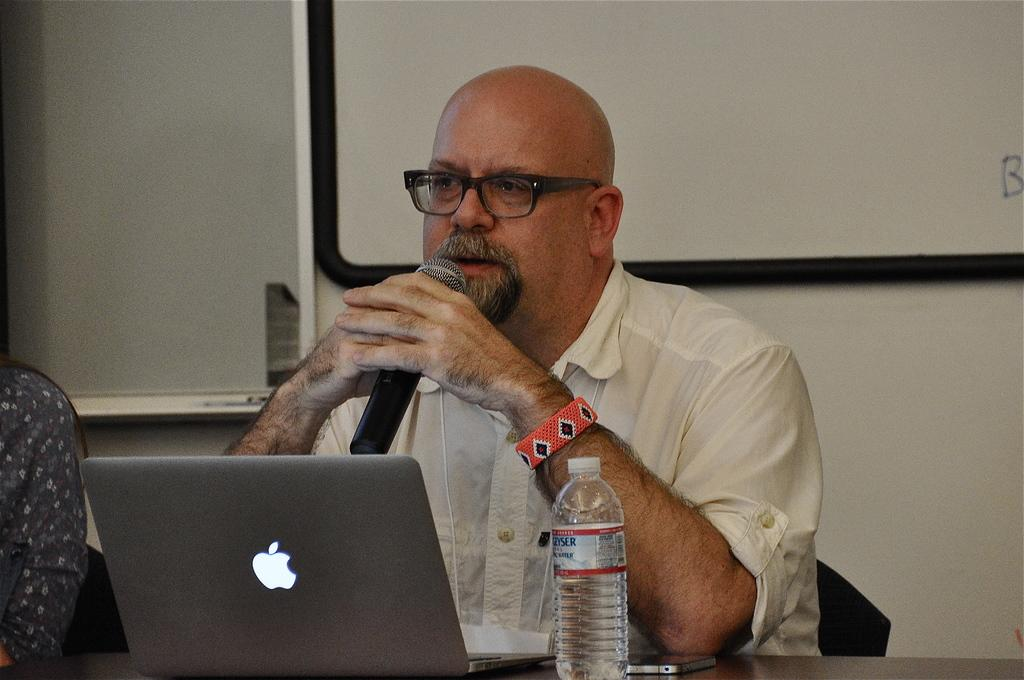What is the main subject of the image? There is a man in the image. What is the man doing in the image? The man is sitting and speaking. What is the man holding in his hand? The man is holding a microphone in his hand. What objects are on the table behind the man? There is a laptop and a water bottle on the table. What other electronic device is on the table? There is a cell phone on the table. What type of island can be seen in the background of the image? There is no island visible in the image; it features a man sitting and speaking with a microphone, a laptop, a water bottle, and a cell phone on the table. What reason does the man have for holding the microphone in the image? The image does not provide any information about the man's reason for holding the microphone, so we cannot determine his motivation from the image alone. 